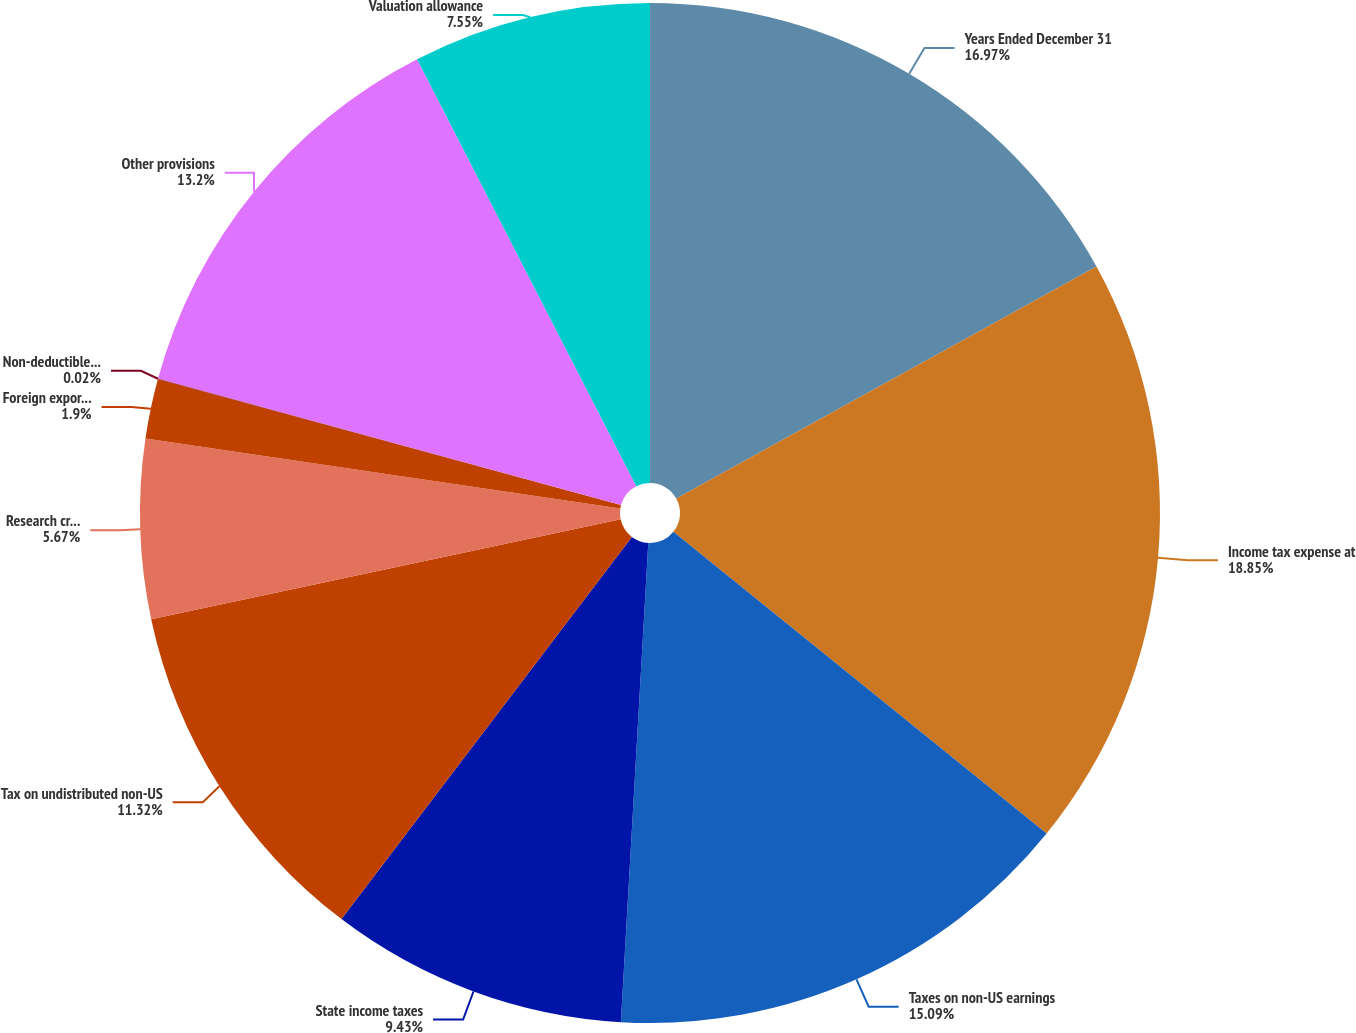Convert chart to OTSL. <chart><loc_0><loc_0><loc_500><loc_500><pie_chart><fcel>Years Ended December 31<fcel>Income tax expense at<fcel>Taxes on non-US earnings<fcel>State income taxes<fcel>Tax on undistributed non-US<fcel>Research credits<fcel>Foreign export sales and<fcel>Non-deductible acquisition<fcel>Other provisions<fcel>Valuation allowance<nl><fcel>16.97%<fcel>18.85%<fcel>15.09%<fcel>9.43%<fcel>11.32%<fcel>5.67%<fcel>1.9%<fcel>0.02%<fcel>13.2%<fcel>7.55%<nl></chart> 